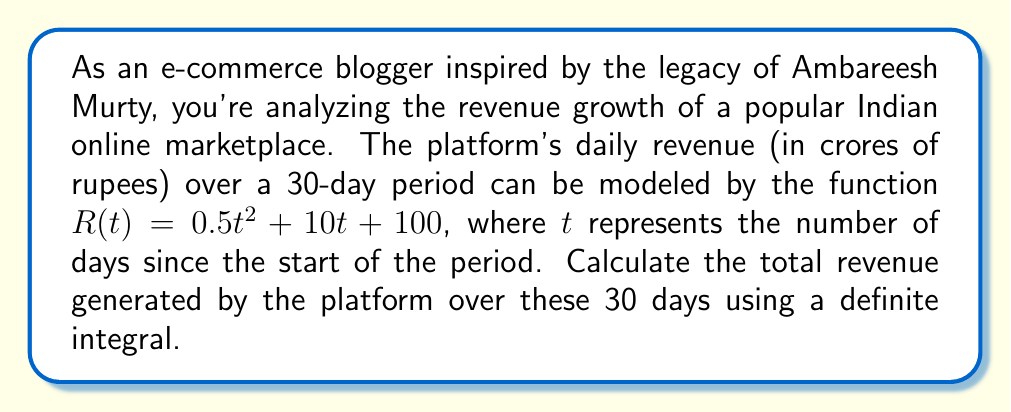Could you help me with this problem? To solve this problem, we need to use definite integration. The total revenue over the 30-day period is represented by the area under the curve of $R(t)$ from $t=0$ to $t=30$. Let's break this down step-by-step:

1) The function for daily revenue is:
   $R(t) = 0.5t^2 + 10t + 100$

2) To find the total revenue, we need to integrate this function from $t=0$ to $t=30$:
   $$\int_0^{30} (0.5t^2 + 10t + 100) dt$$

3) Let's integrate each term separately:
   $$\int_0^{30} 0.5t^2 dt + \int_0^{30} 10t dt + \int_0^{30} 100 dt$$

4) Integrating:
   $$[\frac{1}{6}t^3]_0^{30} + [5t^2]_0^{30} + [100t]_0^{30}$$

5) Evaluating at the limits:
   $$(\frac{1}{6}(30^3) - 0) + (5(30^2) - 0) + (100(30) - 0)$$

6) Simplifying:
   $$4500 + 4500 + 3000 = 12000$$

Therefore, the total revenue over the 30-day period is 12000 crores of rupees.
Answer: ₹12,000 crores 